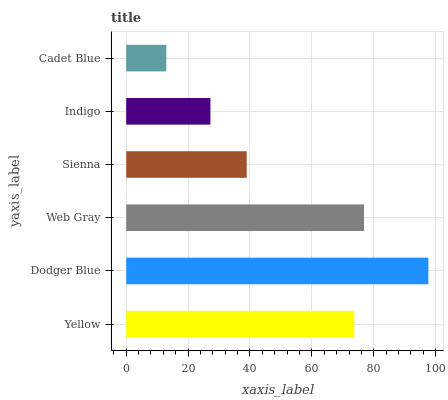Is Cadet Blue the minimum?
Answer yes or no. Yes. Is Dodger Blue the maximum?
Answer yes or no. Yes. Is Web Gray the minimum?
Answer yes or no. No. Is Web Gray the maximum?
Answer yes or no. No. Is Dodger Blue greater than Web Gray?
Answer yes or no. Yes. Is Web Gray less than Dodger Blue?
Answer yes or no. Yes. Is Web Gray greater than Dodger Blue?
Answer yes or no. No. Is Dodger Blue less than Web Gray?
Answer yes or no. No. Is Yellow the high median?
Answer yes or no. Yes. Is Sienna the low median?
Answer yes or no. Yes. Is Web Gray the high median?
Answer yes or no. No. Is Web Gray the low median?
Answer yes or no. No. 